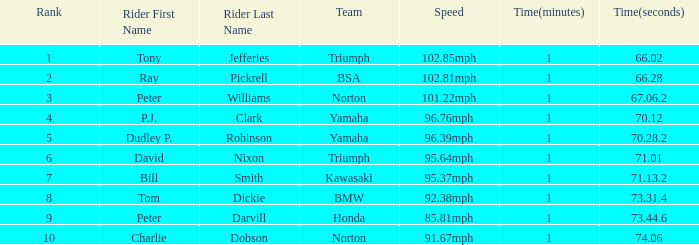How many Ranks have ray pickrell as a Rider? 1.0. 